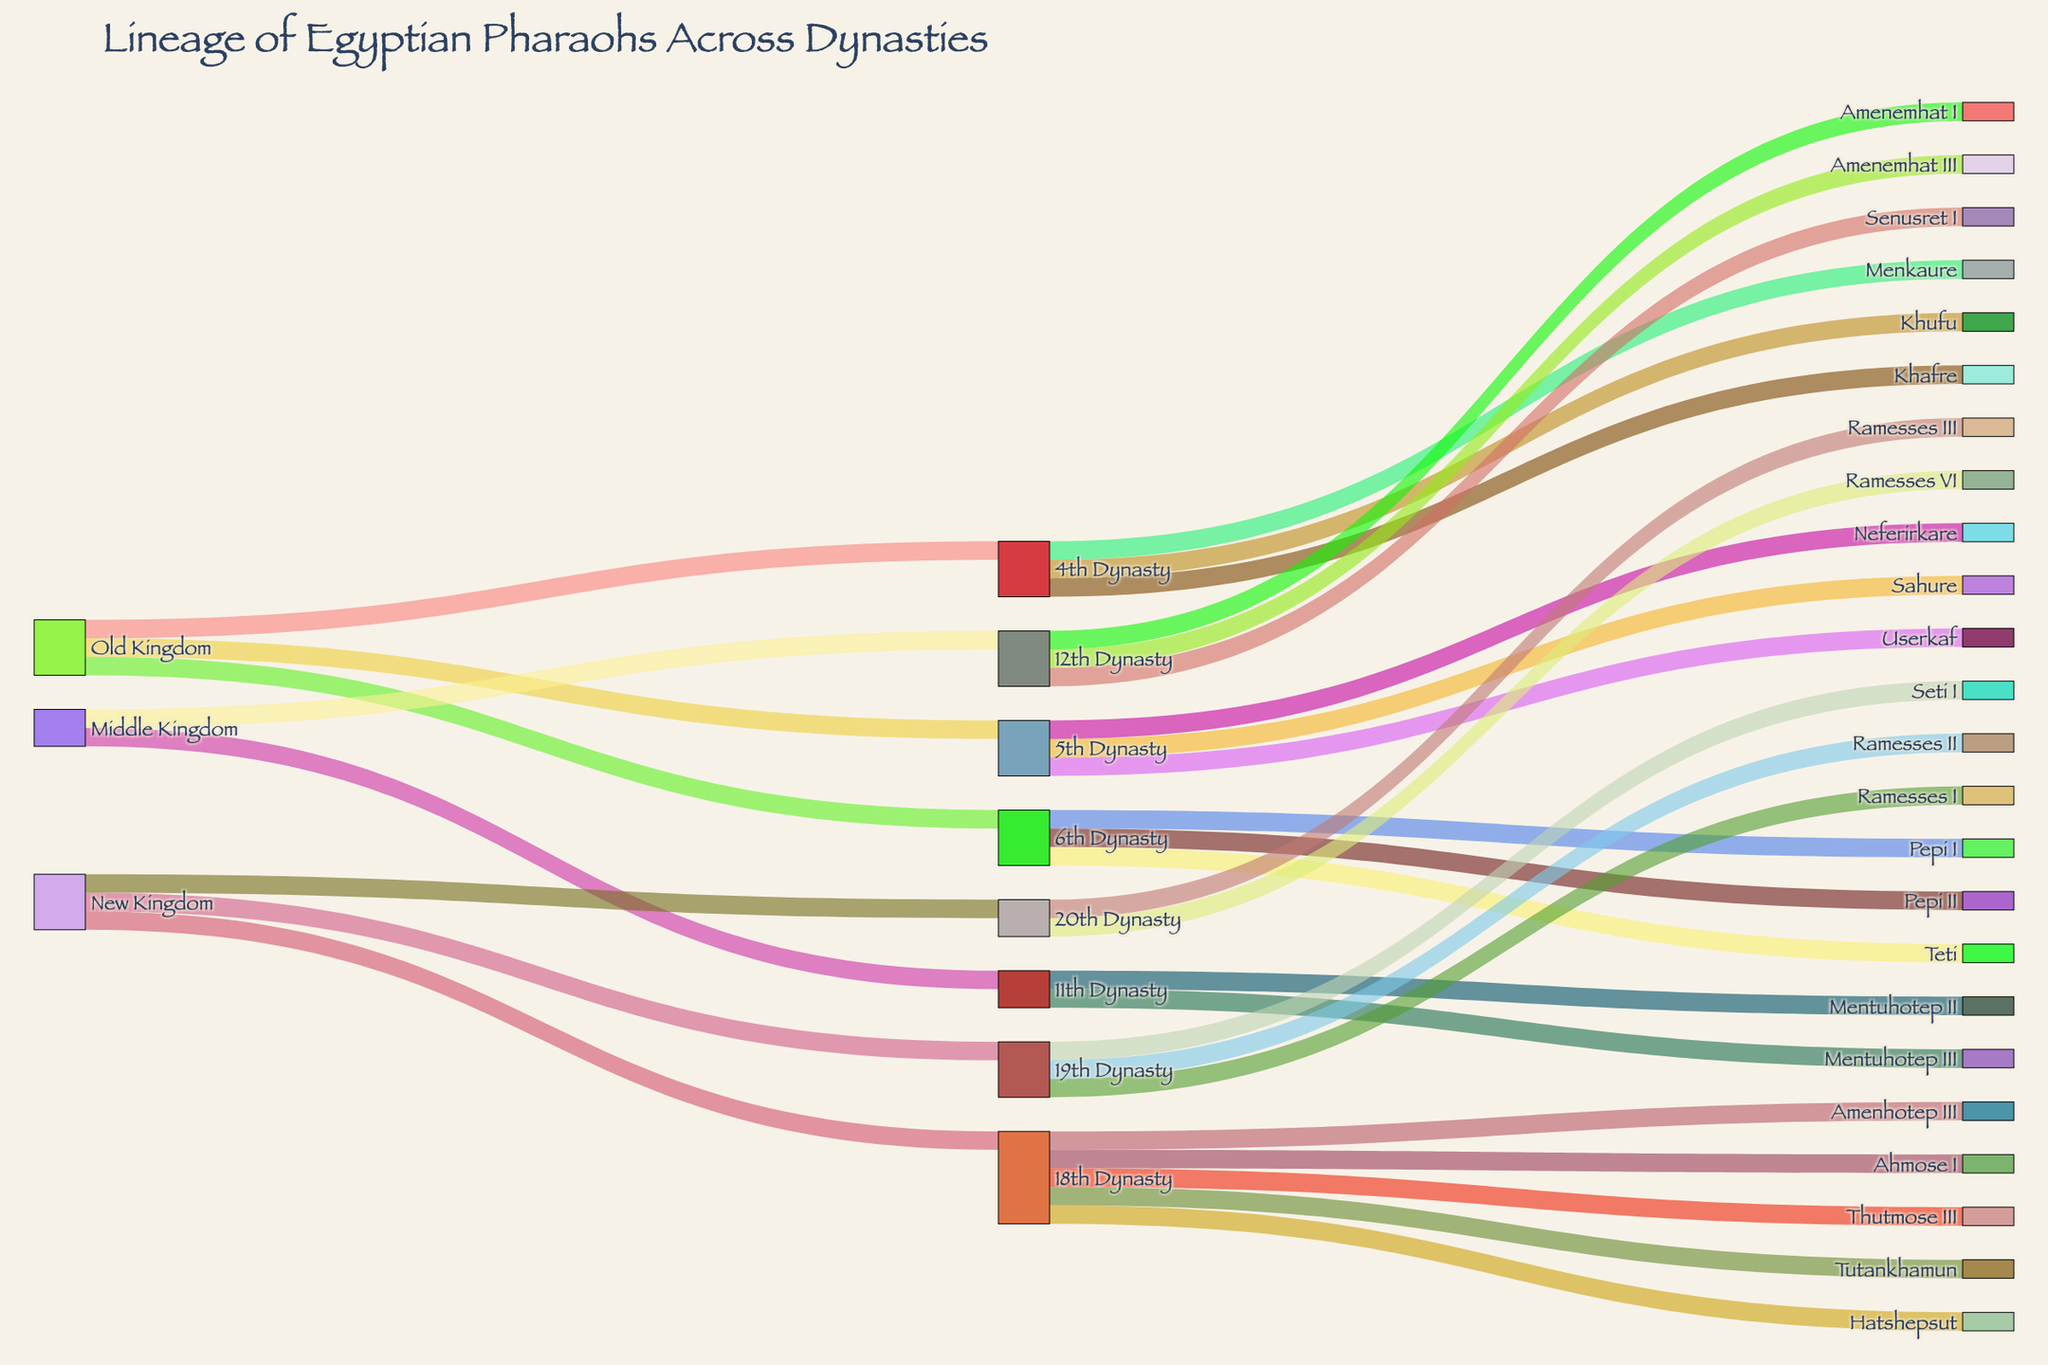Who are the pharaohs listed under the 6th Dynasty? We can see the lineage of pharaohs by following the connections from the "6th Dynasty" node to the final nodes. The 6th Dynasty is connected to three pharaohs: Teti, Pepi I, and Pepi II.
Answer: Teti, Pepi I, Pepi II Which dynasties are part of the Old Kingdom? By identifying the connections starting from "Old Kingdom," we can observe that it branches into three dynasties: the 4th Dynasty, 5th Dynasty, and 6th Dynasty.
Answer: 4th Dynasty, 5th Dynasty, 6th Dynasty How many pharaohs are represented in the New Kingdom? To determine the number of pharaohs in the New Kingdom, count the nodes directly linked to the 18th, 19th, and 20th Dynasties under the "New Kingdom." This results in ten distinct pharaohs.
Answer: 10 Which dynasty in the New Kingdom has the most pharaohs listed, and how many? By examining the connections under each dynasty in the New Kingdom, we see the 18th Dynasty has the most pharaohs listed, with five pharaohs (Ahmose I, Hatshepsut, Thutmose III, Amenhotep III, Tutankhamun).
Answer: 18th Dynasty, 5 Who are the pharaohs from the 11th Dynasty in the Middle Kingdom? Trace the lineage from the "Middle Kingdom" to the "11th Dynasty" and note the connected nodes. The pharaohs listed are Mentuhotep II and Mentuhotep III.
Answer: Mentuhotep II, Mentuhotep III Compare the number of dynasties in each Kingdom displayed in the figure. Which Kingdom has the fewest dynasties, and how many? To compare the number of dynasties, we count the connections directly linked to each Kingdom. The Old Kingdom and New Kingdom each have three dynasties, while the Middle Kingdom has two. Thus, the Middle Kingdom has the fewest dynasties with two.
Answer: Middle Kingdom, 2 Identify the generation that follows Khufu in the lineage. To find the generation following Khufu, we need to observe if Khufu is directly linked to any other nodes. Khufu is not connected to any succeeding pharaohs in this diagram, indicating he doesn’t have a listed successor in the provided data.
Answer: None Are any dynasties from the Middle Kingdom or New Kingdom connected to more pharaohs than any dynasty from the Old Kingdom? If yes, provide the corresponding dynasty and number of pharaohs. Evaluate each dynasty's pharaoh count from Middle and New Kingdoms and compare them to Old Kingdom dynasties (which have 3, 3, and 3 pharaohs respectively). The 18th Dynasty from New Kingdom listing 5 pharaohs surpasses all Old Kingdom dynasties.
Answer: Yes, 18th Dynasty, 5 How many connections (links) are there in total in the Sankey diagram? Each line connecting two nodes in the diagram represents a link. Counting all the links from sources to targets in the dataset gives us 30 connections.
Answer: 30 